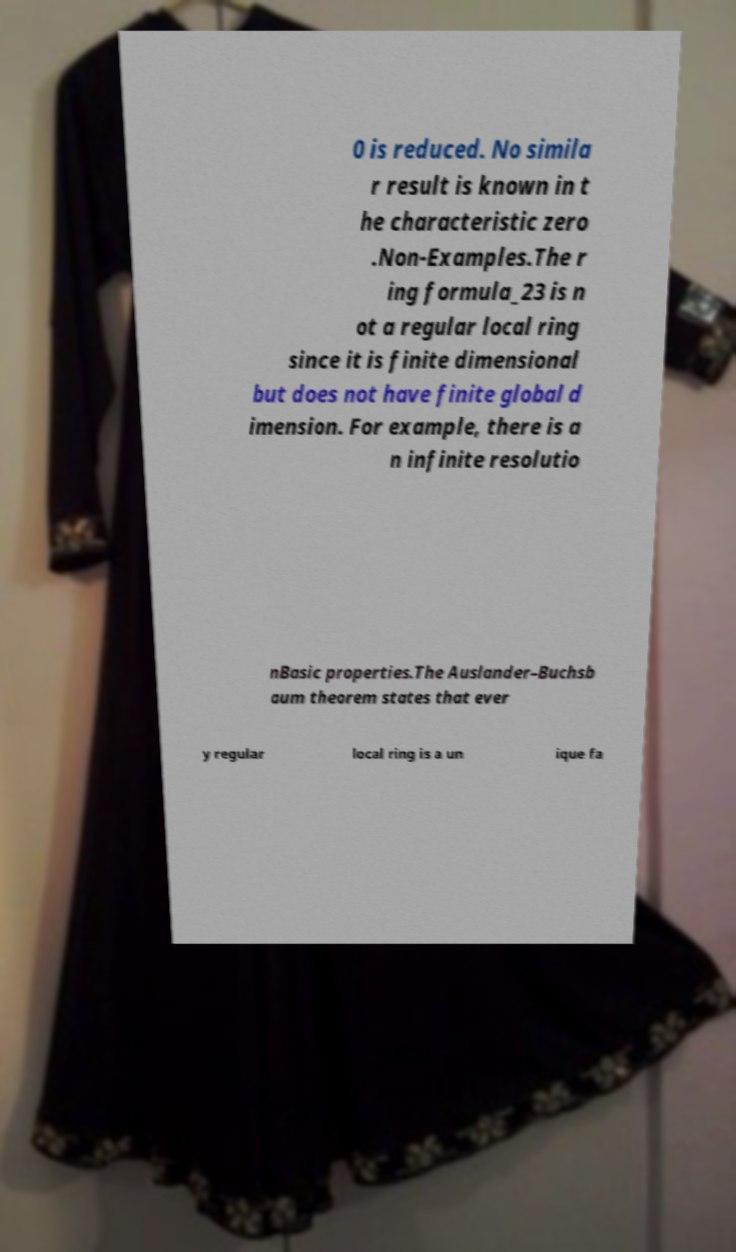I need the written content from this picture converted into text. Can you do that? 0 is reduced. No simila r result is known in t he characteristic zero .Non-Examples.The r ing formula_23 is n ot a regular local ring since it is finite dimensional but does not have finite global d imension. For example, there is a n infinite resolutio nBasic properties.The Auslander–Buchsb aum theorem states that ever y regular local ring is a un ique fa 